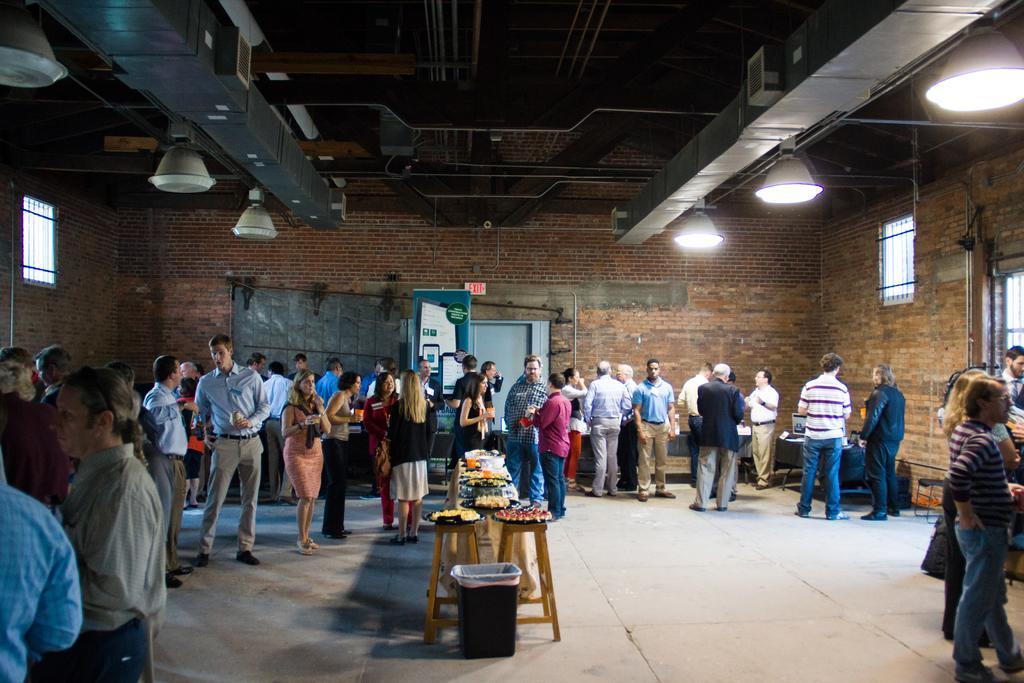Please provide a concise description of this image. In the center of the image there is a table on which there are food items. In the background of the image there are people standing. There is a wall. There is a door. At the top of the image there is a ceiling with lights. To the right side of the image there are windows. At the bottom of the image there is floor. 